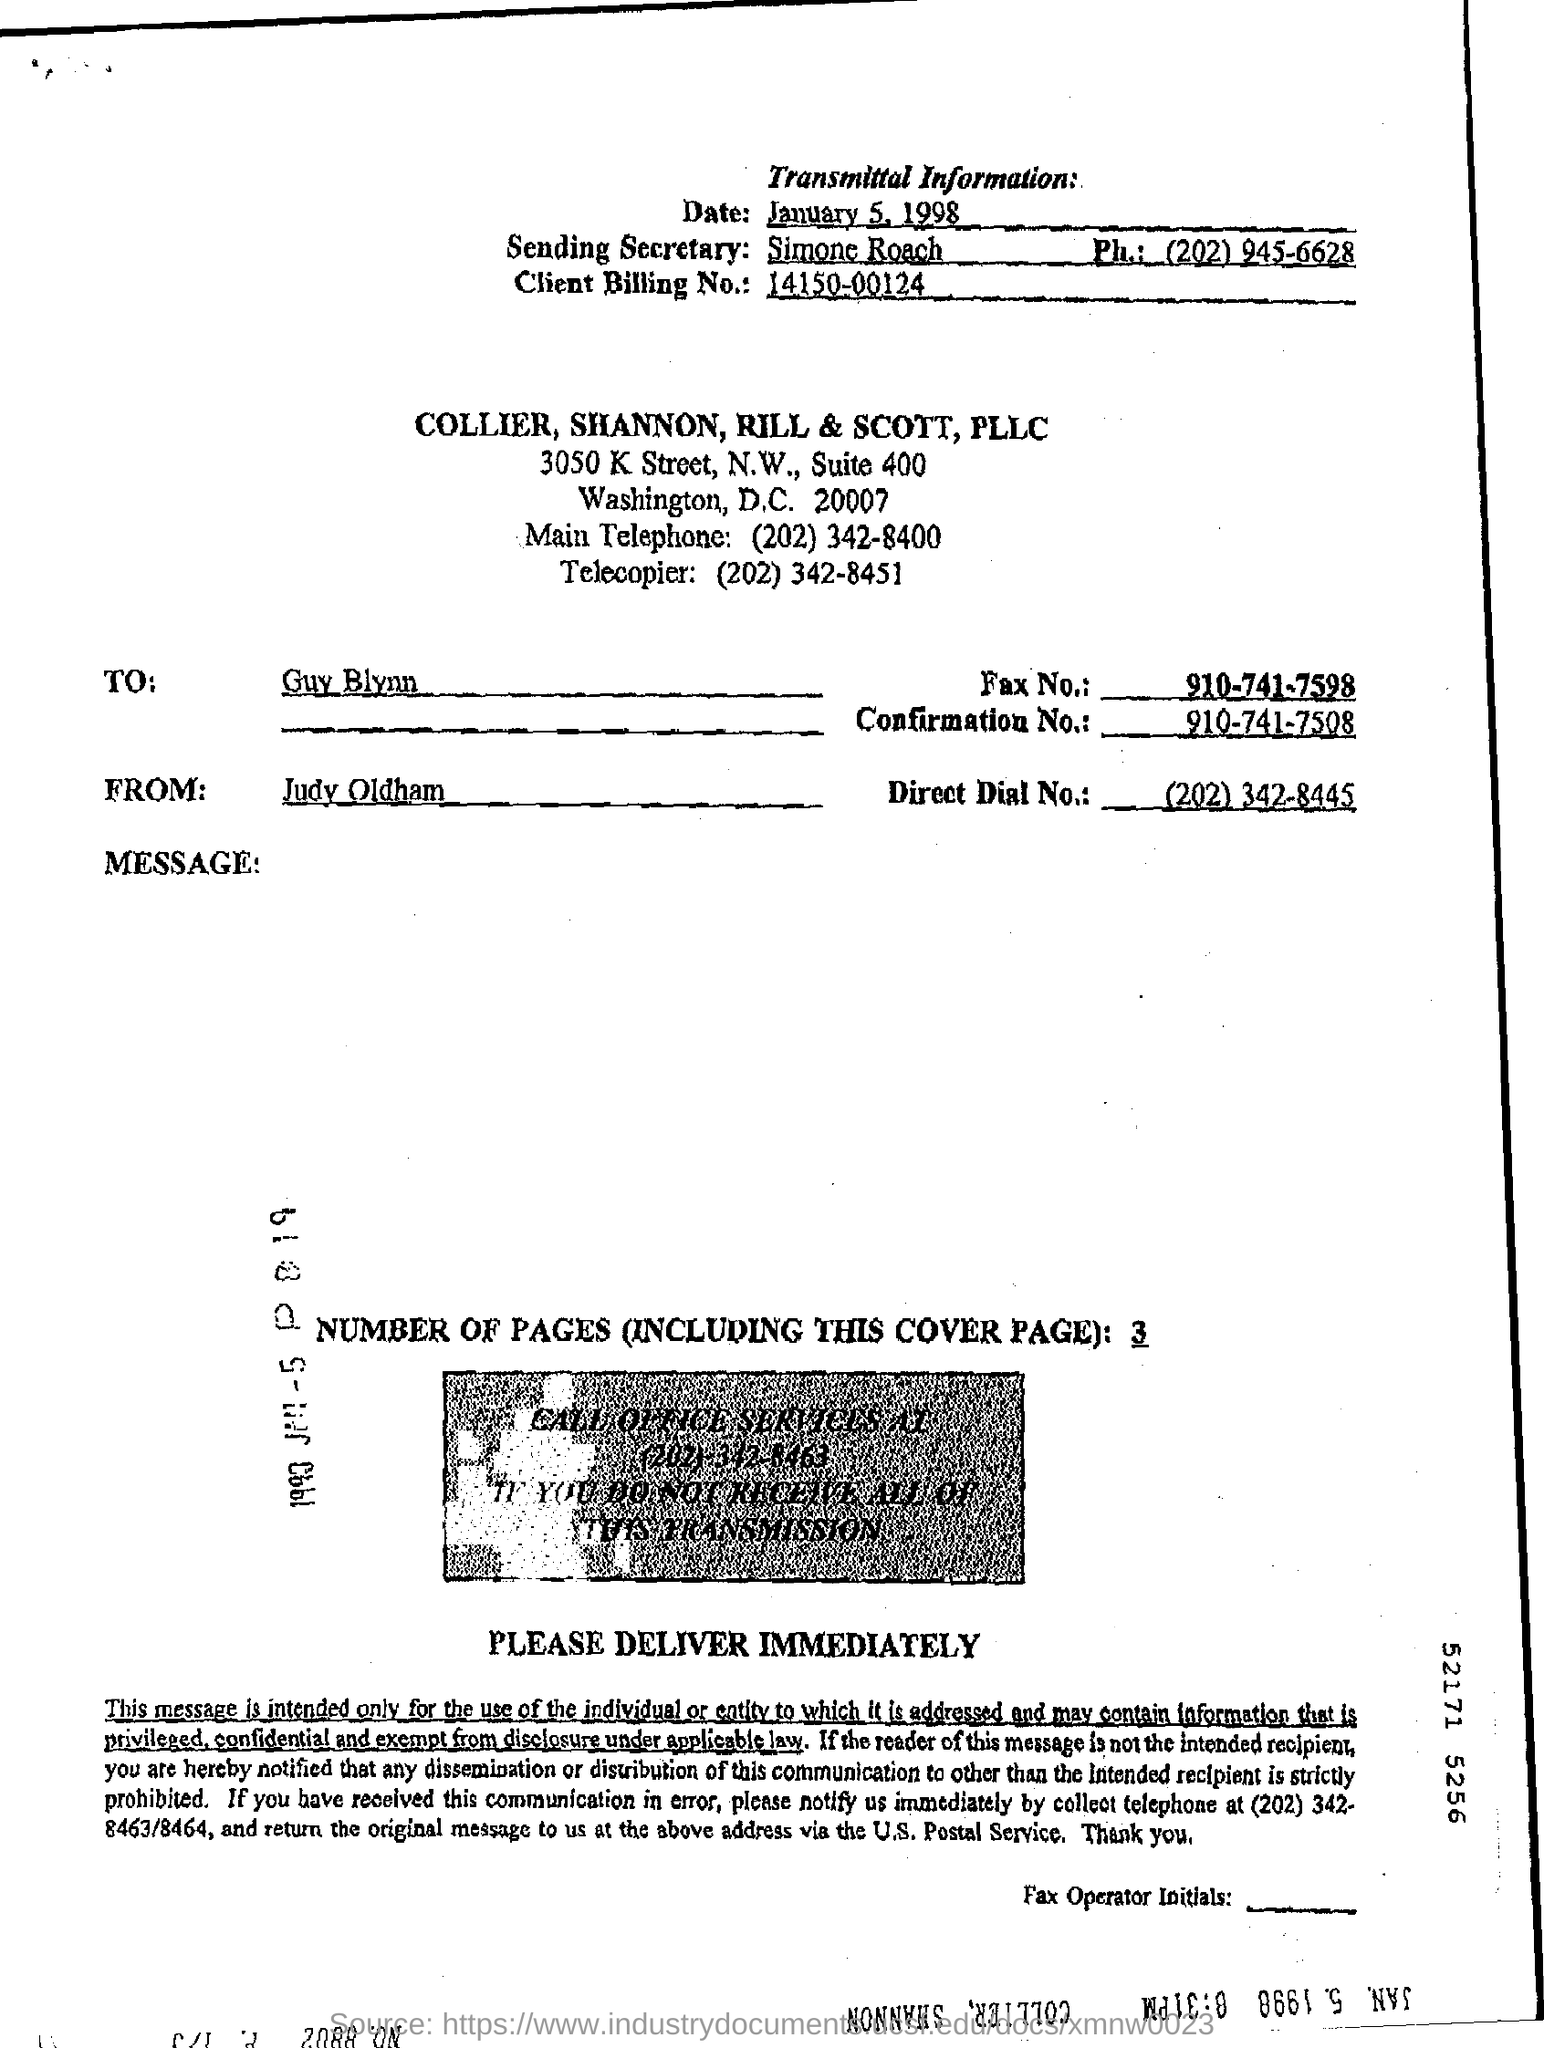Point out several critical features in this image. The transmittal contains a Confirmation No. of 910-741-7508. There are a total of 3 pages, including the cover page, in the fax. The client billing number mentioned in the fax transmittal is 14150-00124... The recipient of the fax is Guy Blynn. The name of the person who is sending this message is Simone Roach. 